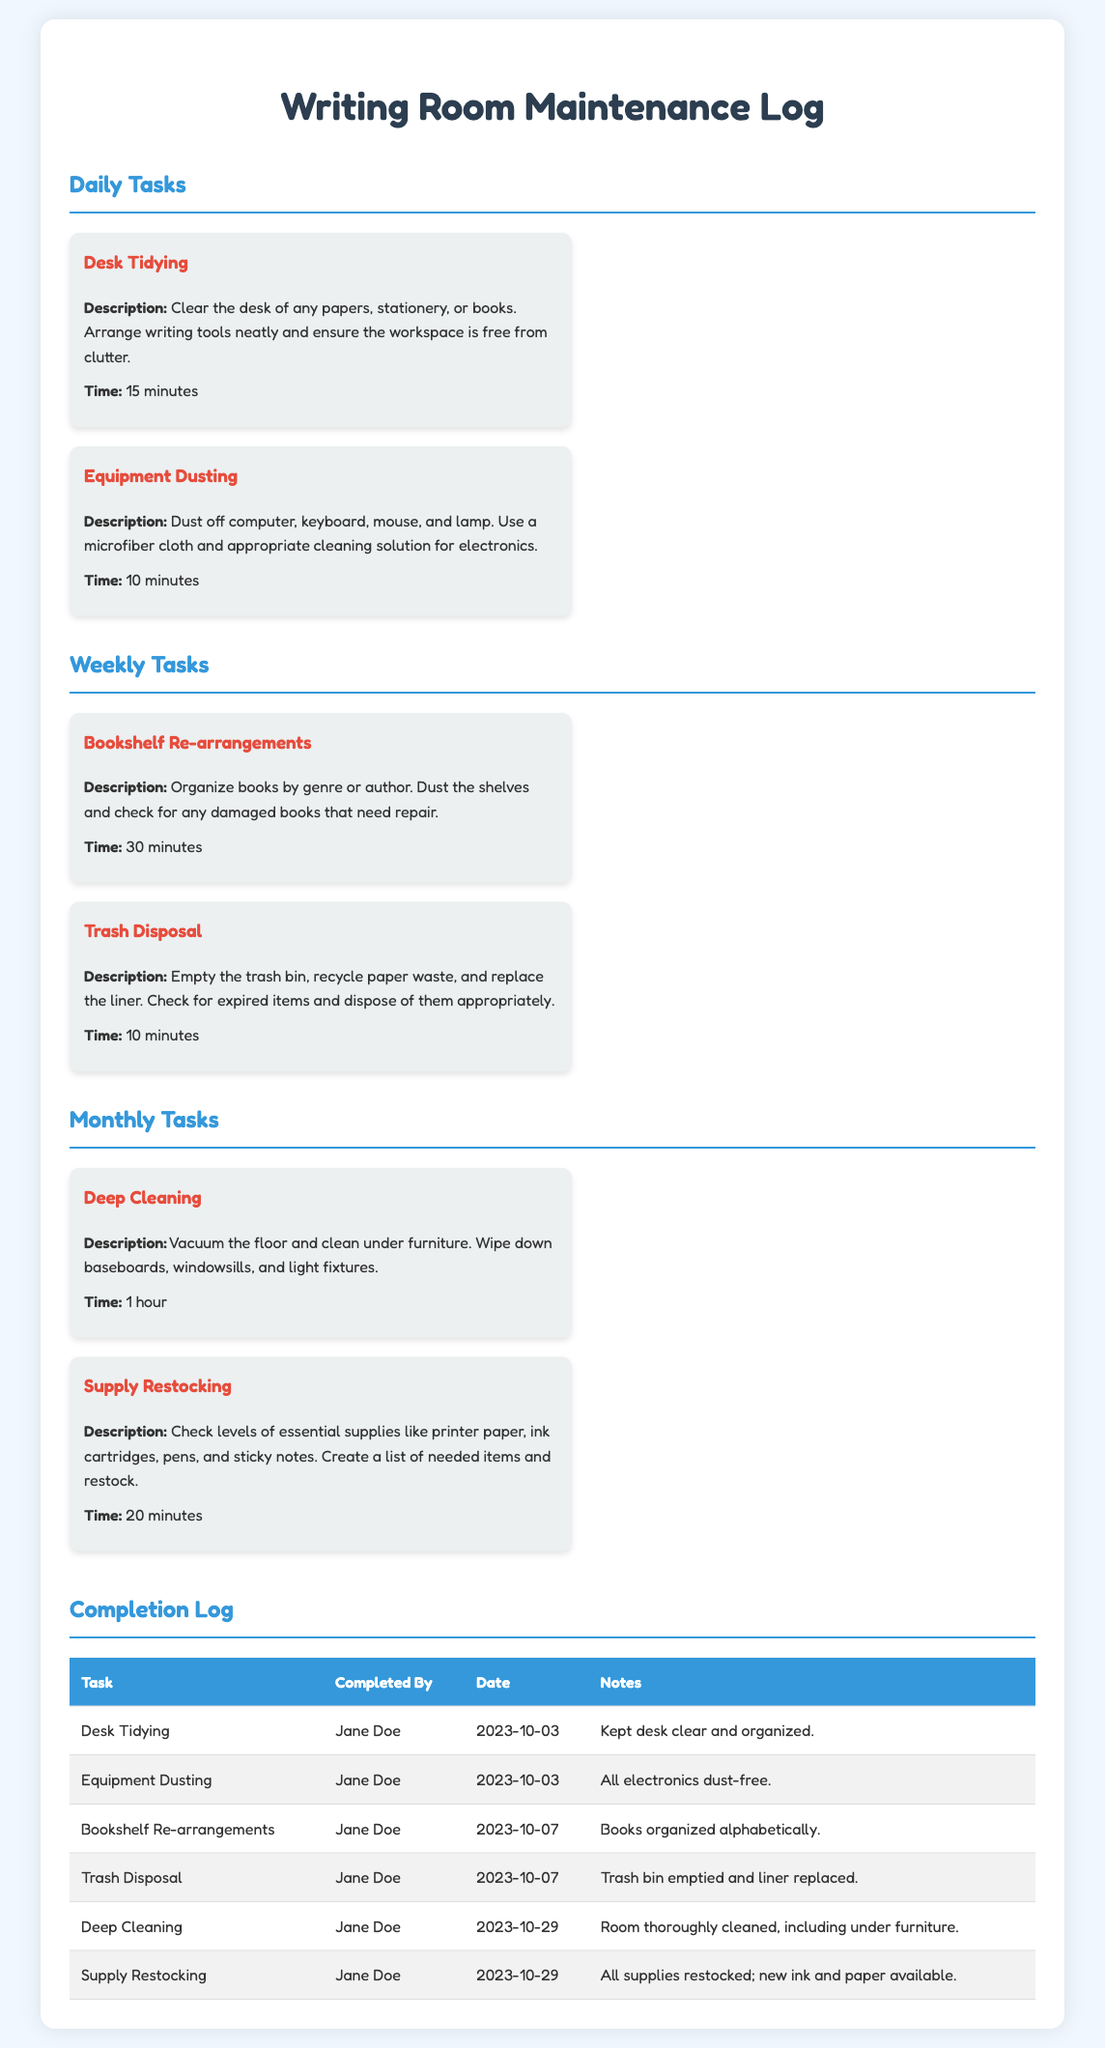what is the title of the document? The title of the document is provided in the header section of the rendered HTML, summarizing the overall content.
Answer: Writing Room Maintenance Log what task takes the longest to complete? The task with the longest duration is listed among the monthly tasks in the document.
Answer: Deep Cleaning how many tasks are listed under Weekly Tasks? The number of tasks under Weekly Tasks can be found in the section dedicated to weekly maintenance activities.
Answer: 2 who completed the Desk Tidying task? The name of the person who completed this specific task is mentioned in the completion log of the document.
Answer: Jane Doe when was the last Supply Restocking done? The date of the last Supply Restocking is recorded in the completion log section, indicating when the task was finished.
Answer: 2023-10-29 which task is described as "Dust off computer, keyboard, mouse, and lamp"? The description of this task is specified in the daily tasks' section detailing its activities.
Answer: Equipment Dusting what is the time allocated for Bookshelf Re-arrangements? The time allocated for this task is stated in the task card under the weekly tasks.
Answer: 30 minutes how often is "Trash Disposal" scheduled? The frequency of this task can be inferred from the listed maintenance schedule in the document.
Answer: Weekly which task involves checking for damaged books? The task that mentions this specific activity is detailed in the weekly tasks section.
Answer: Bookshelf Re-arrangements 